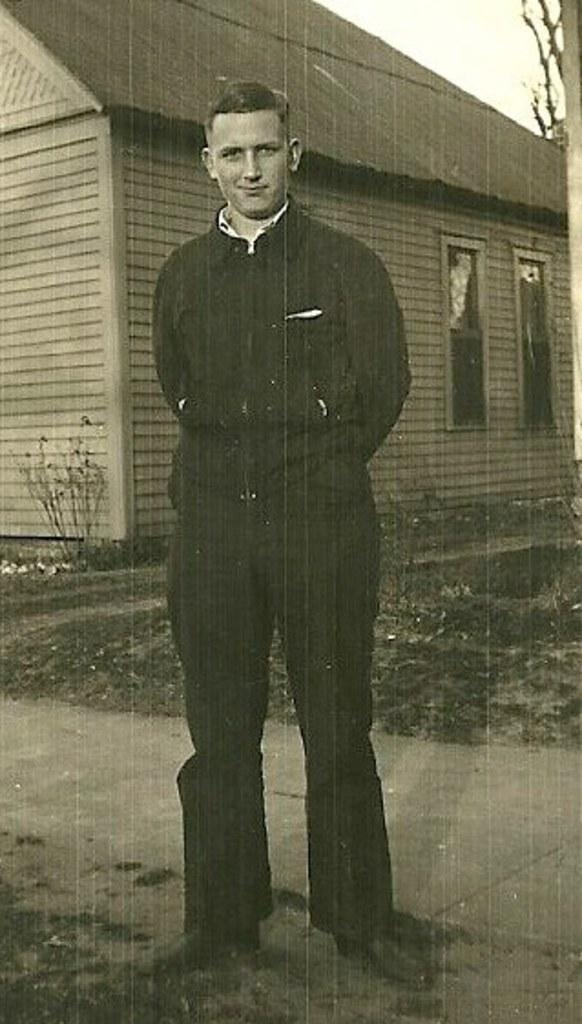Who or what is the main subject of the image? There is a person in the image. What is the person wearing? The person is wearing a black dress. What is the person doing in the image? The person is standing. What can be seen in the background of the image? There is a house in the background of the image. What language is the person speaking in the image? There is no indication of the person speaking in the image, so it cannot be determined which language they might be using. 